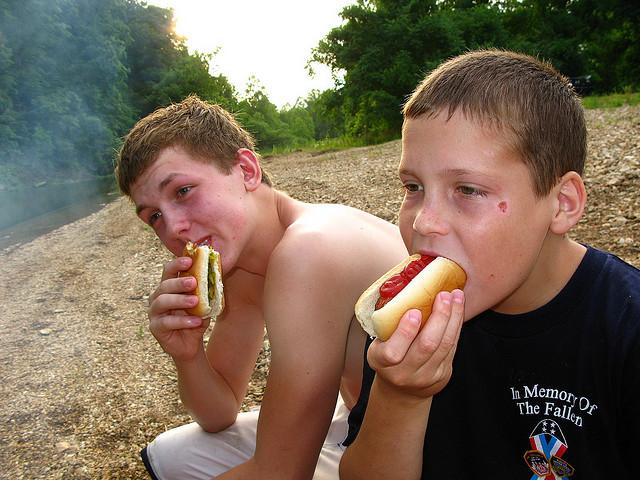What are the boys eating?
Keep it brief. Hot dogs. What is the weather?
Be succinct. Hot. What color is the person's shirt?
Give a very brief answer. Blue. 